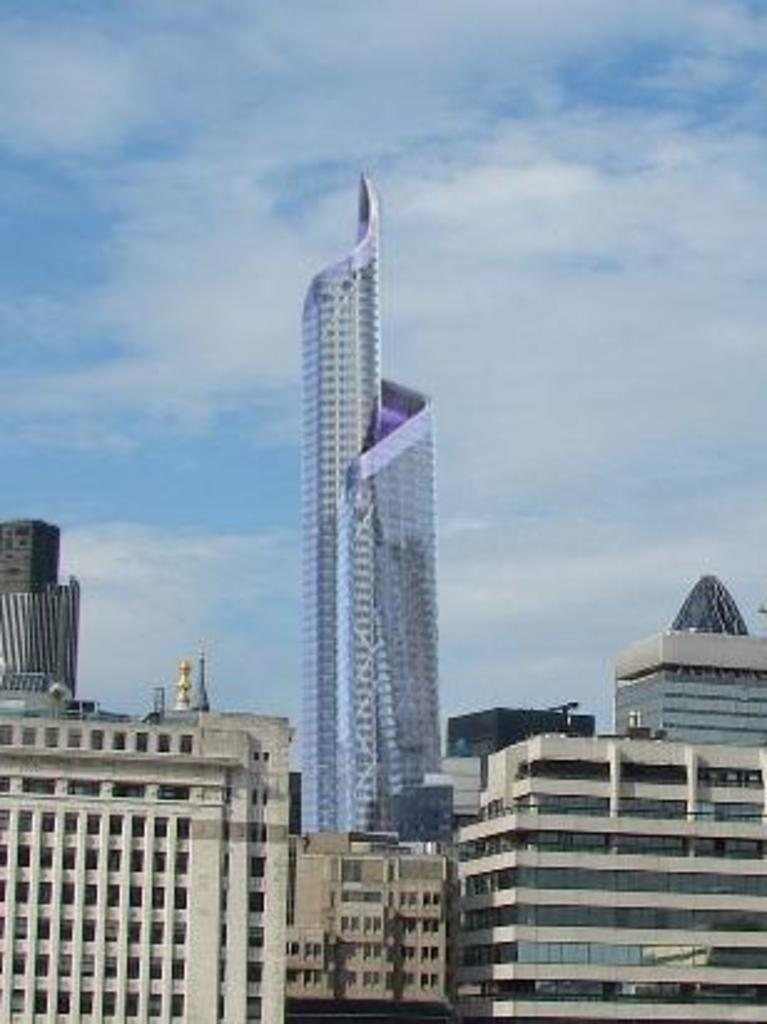What type of structures are located at the bottom of the image? There are buildings at the bottom of the image. What objects can be seen in the image that are typically used for drinking? There are glasses in the image. What architectural elements are present in the image? There are walls and pillars in the image. What tall structure is visible in the image? There is a tower in the image. What is visible in the background of the image? The sky is visible in the background of the image. What type of plough can be seen in the image? There is no plough present in the image. What color is the vein visible in the image? There are no veins visible in the image; it is an architectural scene. 